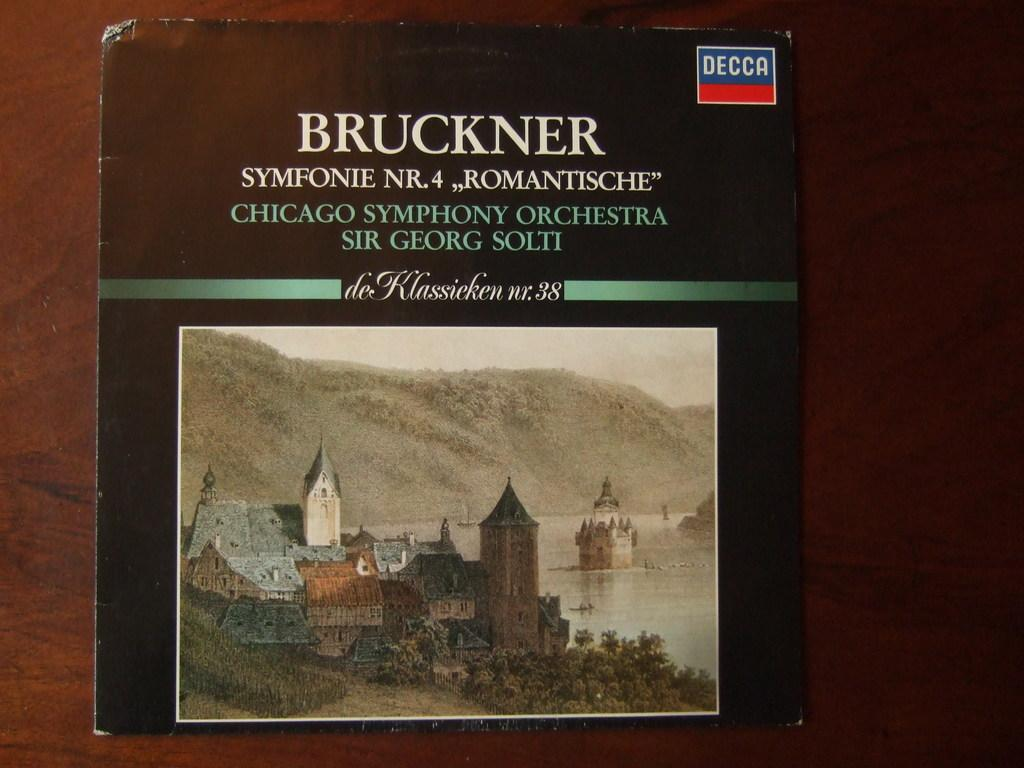<image>
Create a compact narrative representing the image presented. A CD of the Bruckner 4th symphony conducted by Sir Georg Solti 